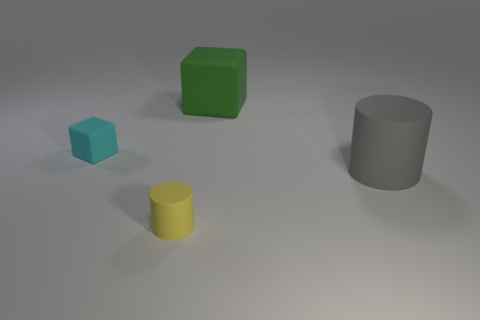Add 4 tiny matte blocks. How many objects exist? 8 Add 3 small yellow matte cylinders. How many small yellow matte cylinders exist? 4 Subtract 0 red spheres. How many objects are left? 4 Subtract all green rubber blocks. Subtract all gray objects. How many objects are left? 2 Add 3 big green matte objects. How many big green matte objects are left? 4 